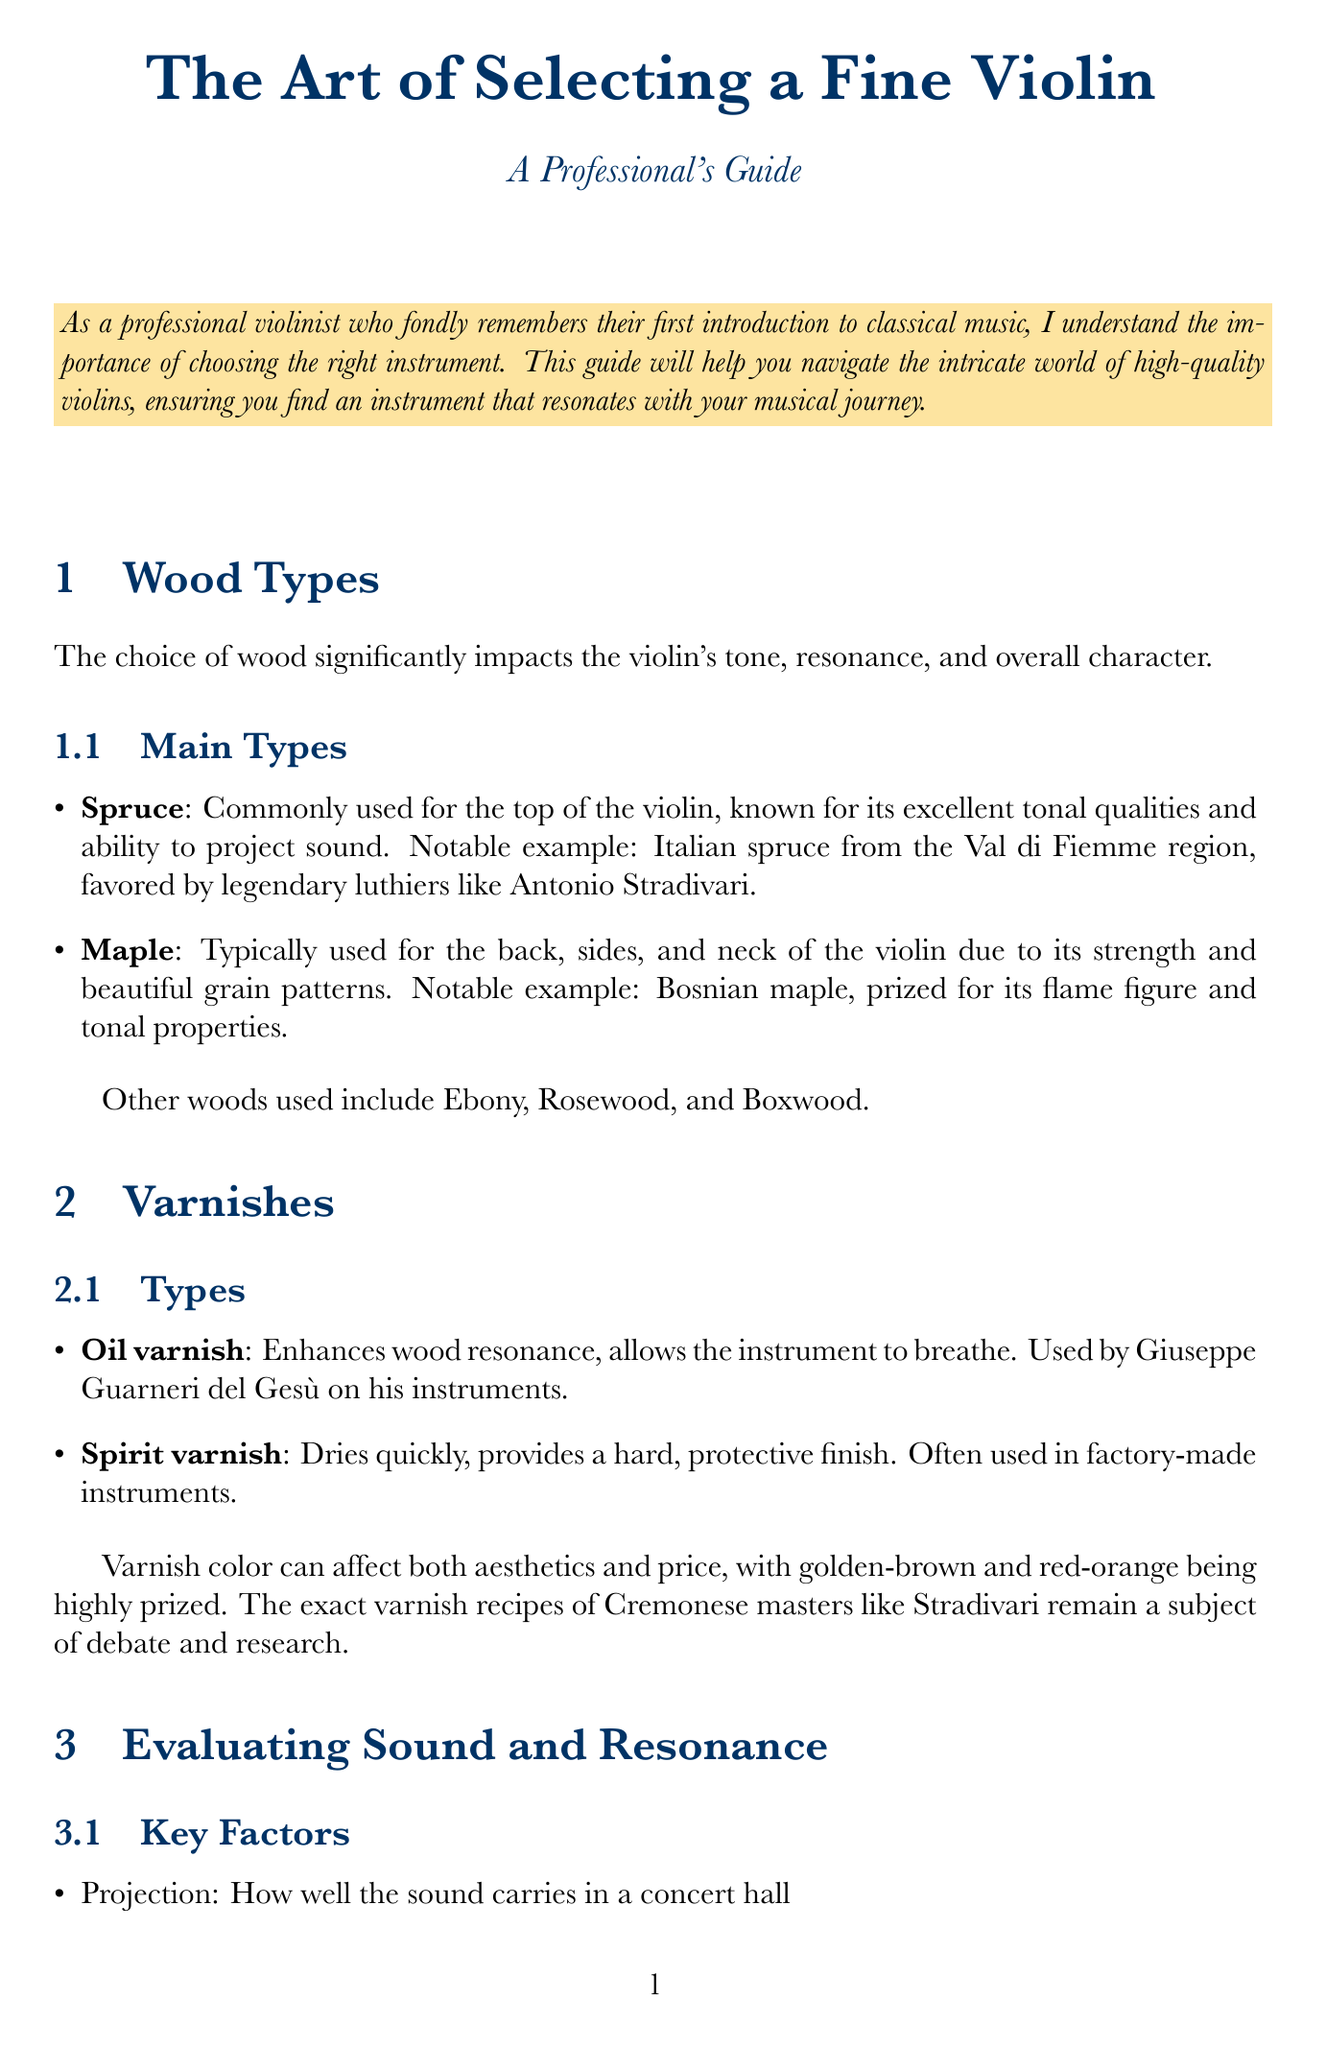what is the main use of spruce in violins? Spruce is commonly used for the top of the violin, known for its excellent tonal qualities and ability to project sound.
Answer: top of the violin who is a notable user of oil varnish? Oil varnish was used by Giuseppe Guarneri del Gesù on his instruments.
Answer: Giuseppe Guarneri del Gesù what is the price range for professional violins? The price range for professional violins is $30,000 - $200,000+.
Answer: $30,000 - $200,000+ which wood is typically used for the back of violins? Maple is typically used for the back, sides, and neck of the violin.
Answer: Maple what should you do after each use of the violin? After each use, you should wipe down the instrument and strings.
Answer: wipe down the instrument and strings name one of the testing methods for evaluating sound. One testing method is to play scales in different positions to check for consistency across the range.
Answer: play scales in different positions who are some of the experts for violin authentication? Experts include Christopher Reuning, Jason Price, and Florian Leonhard.
Answer: Christopher Reuning, Jason Price, Florian Leonhard what is the significance of varnish color? Varnish color can affect both aesthetics and price, with golden-brown and red-orange being highly prized.
Answer: aesthetics and price how often should you replace strings? Strings should be replaced every 3-6 months or as needed.
Answer: every 3-6 months 